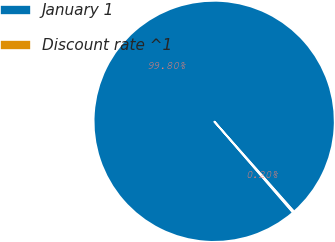Convert chart. <chart><loc_0><loc_0><loc_500><loc_500><pie_chart><fcel>January 1<fcel>Discount rate ^1<nl><fcel>99.8%<fcel>0.2%<nl></chart> 